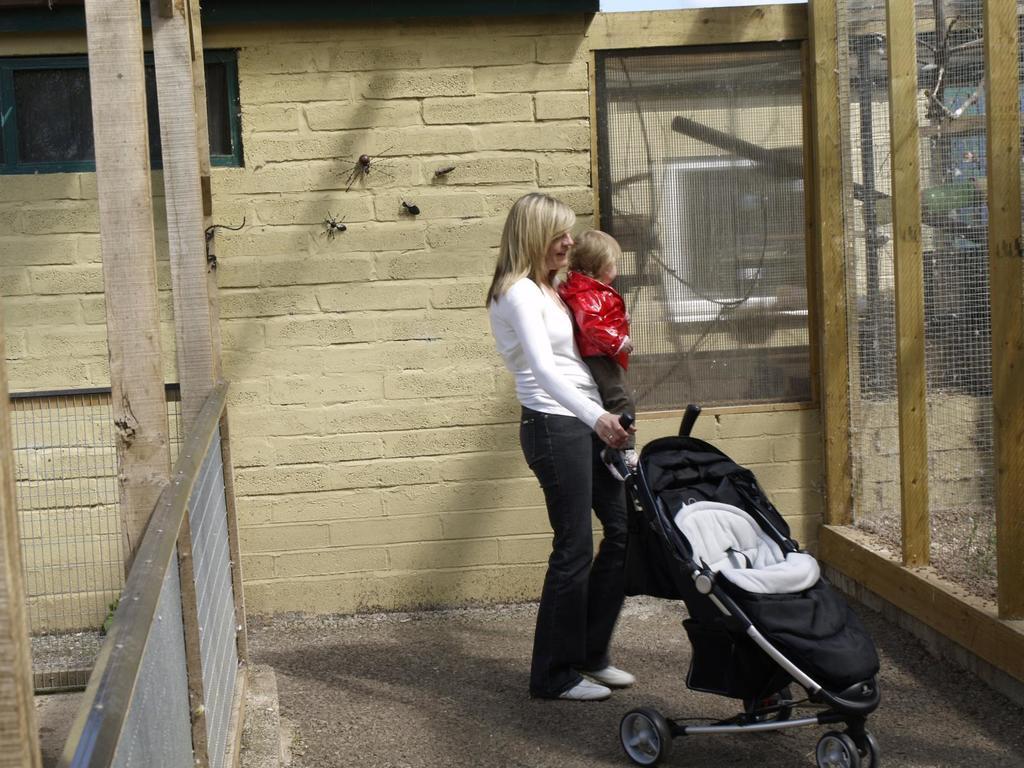Can you describe this image briefly? In this image there is a lady holding a baby. She is holding the handle of a stroller. These are net boundaries. In the background there are spiders on the wall. 